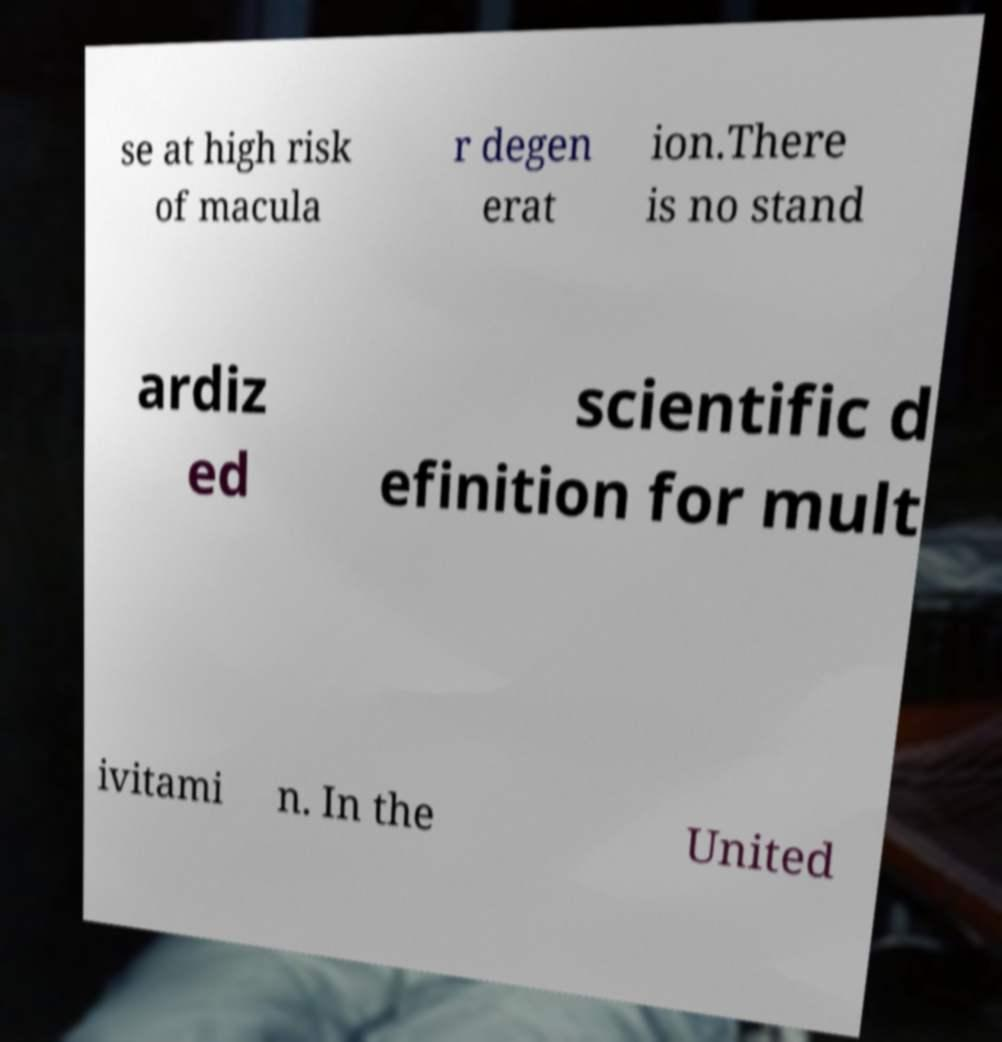There's text embedded in this image that I need extracted. Can you transcribe it verbatim? se at high risk of macula r degen erat ion.There is no stand ardiz ed scientific d efinition for mult ivitami n. In the United 